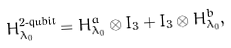Convert formula to latex. <formula><loc_0><loc_0><loc_500><loc_500>H _ { \lambda _ { 0 } } ^ { \text {2-qubit} } = H _ { \lambda _ { 0 } } ^ { a } \otimes I _ { 3 } + I _ { 3 } \otimes H _ { \lambda _ { 0 } } ^ { b } ,</formula> 